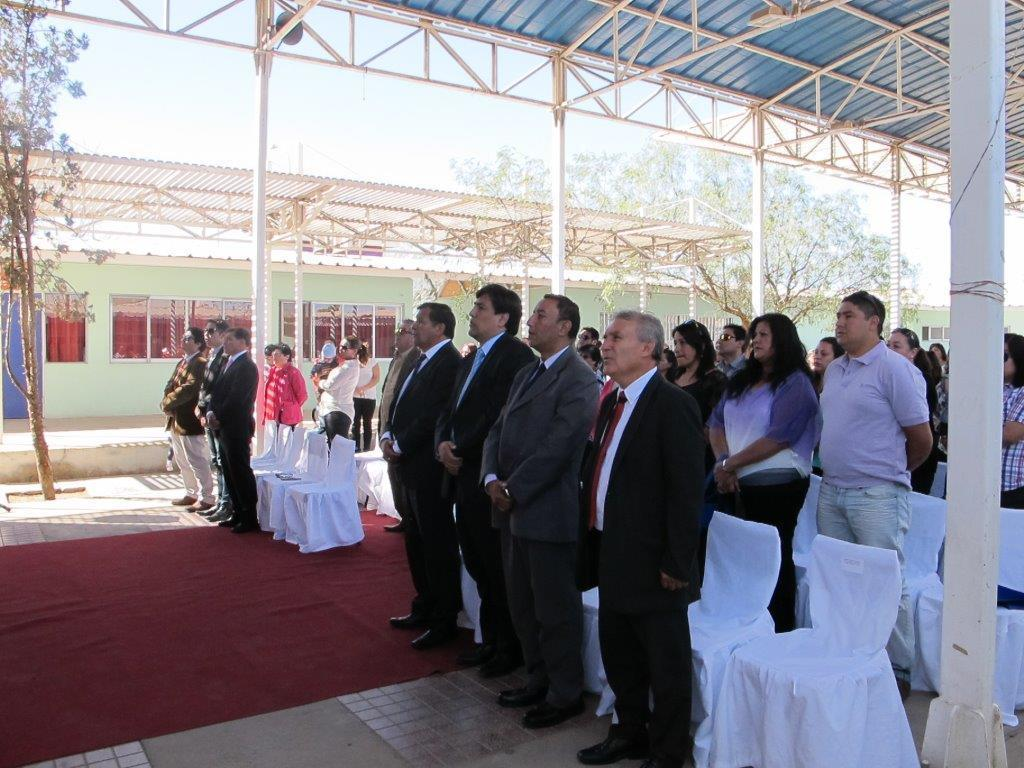What is happening in the center of the image? A: There are people standing in the center of the image. What type of furniture is present in the image? There are chairs in the image. What can be seen in the background of the image? There are sheds, trees, and the sky visible in the background of the image. What is at the bottom of the image? There is a carpet at the bottom of the image. Can you tell me how many eggs are on the chairs in the image? There are no eggs present on the chairs in the image. What type of cable is connecting the sheds in the image? There is no cable connecting the sheds in the image. 